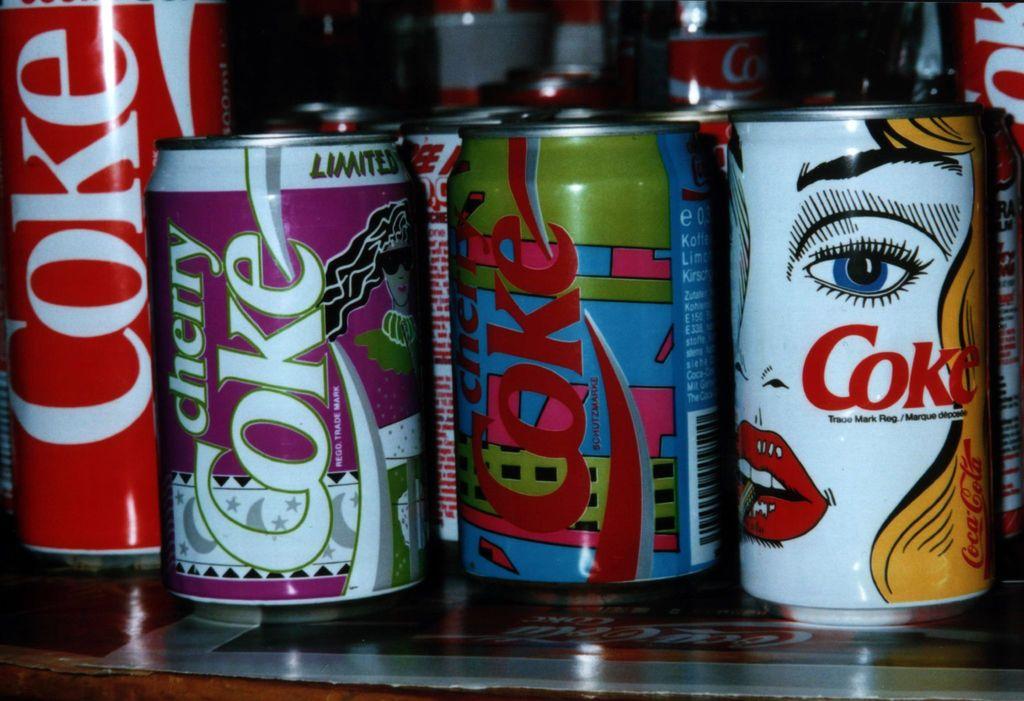What brand is listed on the cans?
Offer a very short reply. Coke. What flavor coke is displayed on the purple background?
Give a very brief answer. Cherry. 